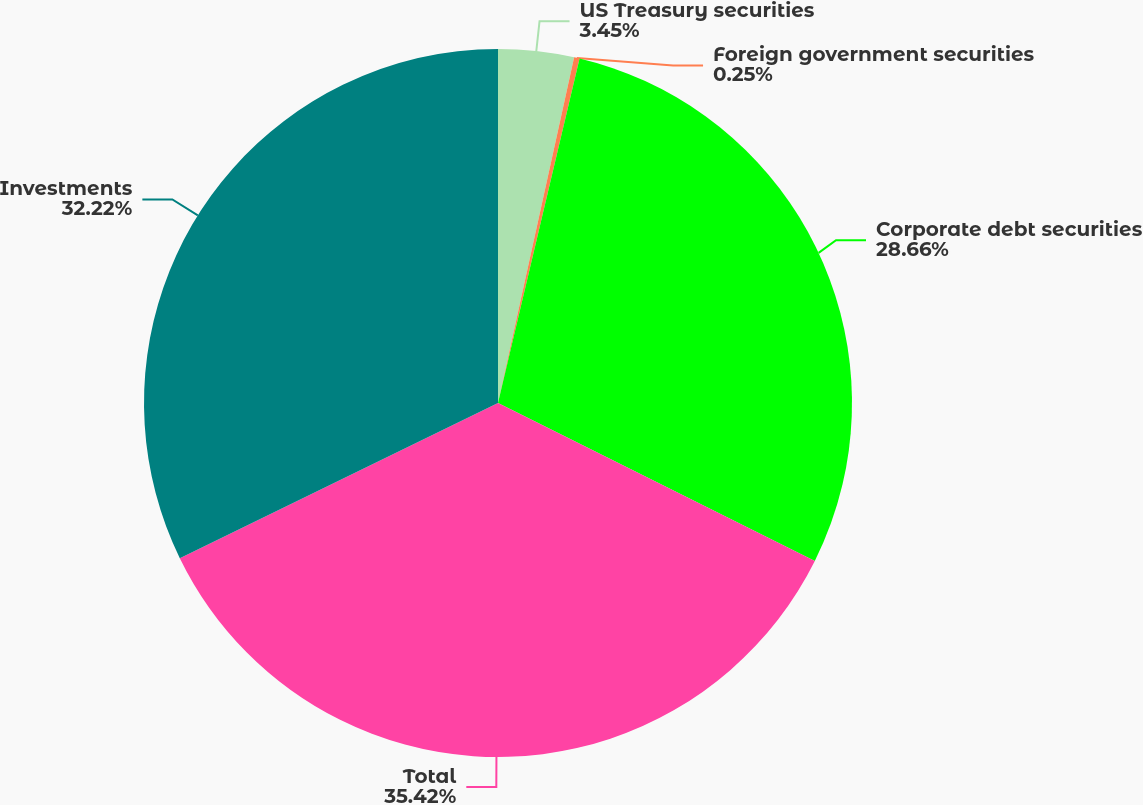Convert chart to OTSL. <chart><loc_0><loc_0><loc_500><loc_500><pie_chart><fcel>US Treasury securities<fcel>Foreign government securities<fcel>Corporate debt securities<fcel>Total<fcel>Investments<nl><fcel>3.45%<fcel>0.25%<fcel>28.66%<fcel>35.42%<fcel>32.22%<nl></chart> 